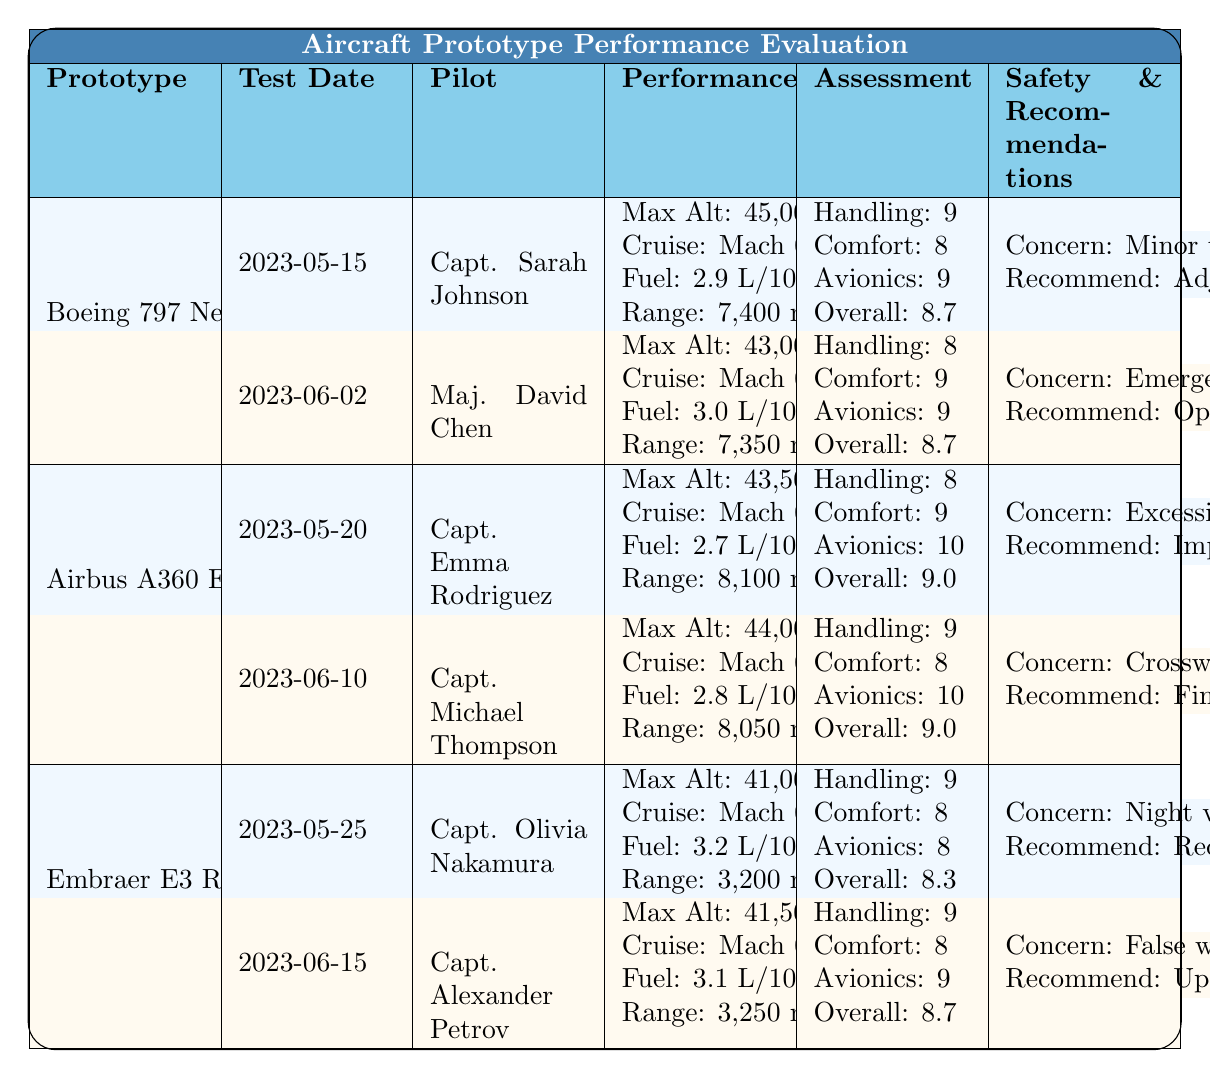What is the maximum altitude recorded for the Boeing 797 NextGen? From the table, the maximum altitude for the Boeing 797 NextGen is listed as 45,000 ft, which is reported during the flight test conducted on 2023-05-15 by Capt. Sarah Johnson.
Answer: 45,000 ft Which pilot conducted the flight test for the Airbus A360 EcoFlex on 2023-06-10? According to the table, the flight test for the Airbus A360 EcoFlex on 2023-06-10 was conducted by Capt. Michael Thompson.
Answer: Capt. Michael Thompson What was the overall assessment score by Maj. David Chen for the Boeing 797 NextGen? Referring to the performance metrics section in the table, Maj. David Chen gave an overall assessment score of 8.7 during the test on 2023-06-02.
Answer: 8.7 What is the difference in maximum altitude between the Airbus A360 EcoFlex and the Embraer E3 Regional? The Airbus A360 EcoFlex has a maximum altitude of 44,000 ft (on 2023-06-10) and the Embraer E3 Regional has a maximum altitude of 41,500 ft (on 2023-06-15). The difference is 44,000 ft - 41,500 ft = 2,500 ft.
Answer: 2,500 ft Did any of the pilots report safety concerns related to turbulence? Capt. Sarah Johnson reported minor turbulence handling issues for the Boeing 797 NextGen, which confirms a safety concern related to turbulence.
Answer: Yes What is the average comfort score reported for the pilots across the Boeing 797 NextGen tests? The comfort scores for the two tests are 8 and 9. To find the average, sum these scores (8 + 9 = 17) and divide by the number of tests (2). Therefore, the average comfort score is 17 / 2 = 8.5.
Answer: 8.5 Which aircraft had the highest overall pilot assessment score? The Airbus A360 EcoFlex scored an overall assessment of 9.0 in both tests (2023-05-20 and 2023-06-10), which is higher than all others.
Answer: Airbus A360 EcoFlex What safety concern was reported for the Embraer E3 Regional? The safety concern for the Embraer E3 Regional, as per the table, was reduced visibility in the cockpit during night operations, reported by Capt. Olivia Nakamura.
Answer: Reduced visibility in cockpit during night operations What was the recommended change for the Boeing 797 NextGen to improve stability? The recommendation suggested adjusting the wing design to enhance high-altitude stability based on the minor turbulence handling issues reported.
Answer: Adjust wing design for stability Which test date had the highest cruise speed and what was it? For the 2023-05-20 test for the Airbus A360 EcoFlex, the cruise speed of Mach 0.87 is the highest compared to others.
Answer: 2023-05-20, Mach 0.87 